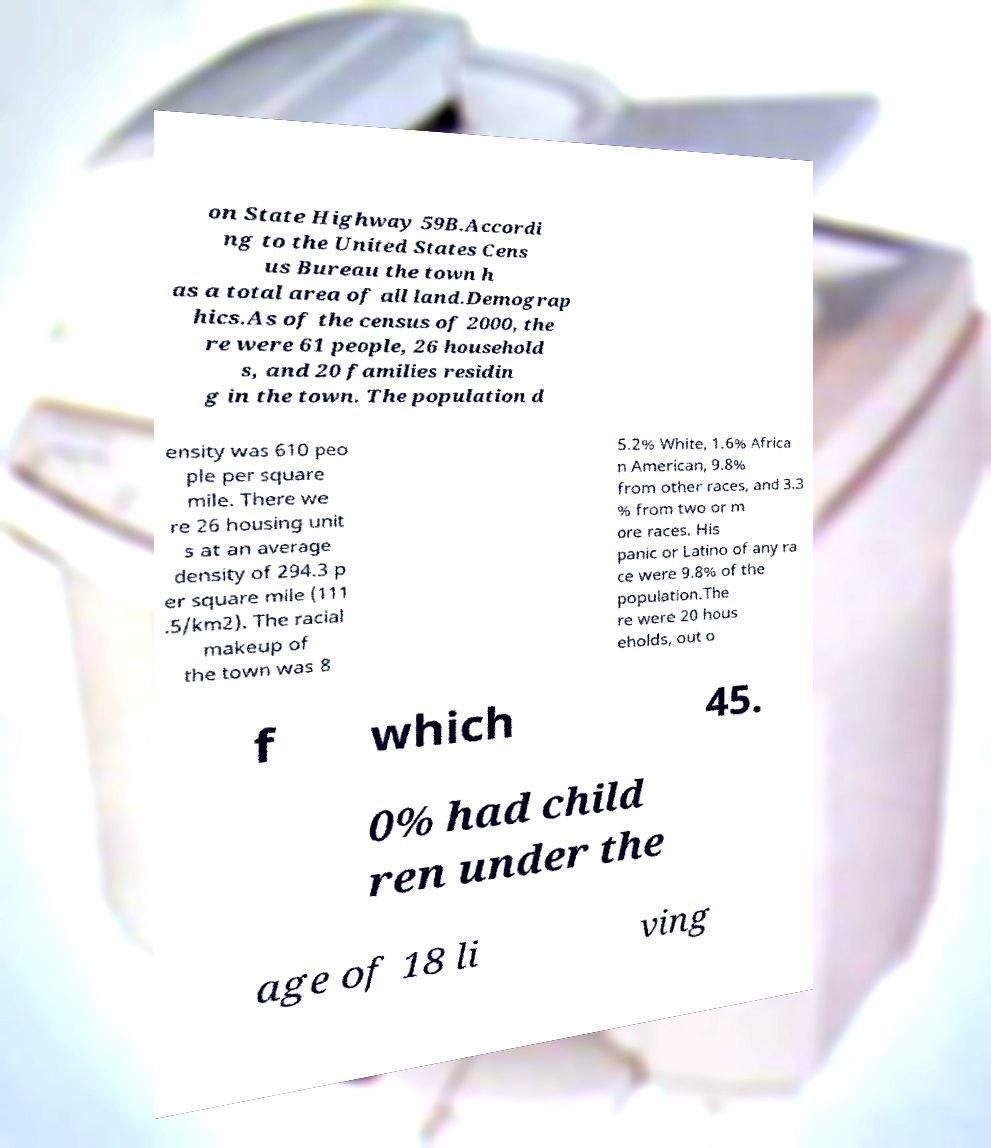What messages or text are displayed in this image? I need them in a readable, typed format. on State Highway 59B.Accordi ng to the United States Cens us Bureau the town h as a total area of all land.Demograp hics.As of the census of 2000, the re were 61 people, 26 household s, and 20 families residin g in the town. The population d ensity was 610 peo ple per square mile. There we re 26 housing unit s at an average density of 294.3 p er square mile (111 .5/km2). The racial makeup of the town was 8 5.2% White, 1.6% Africa n American, 9.8% from other races, and 3.3 % from two or m ore races. His panic or Latino of any ra ce were 9.8% of the population.The re were 20 hous eholds, out o f which 45. 0% had child ren under the age of 18 li ving 